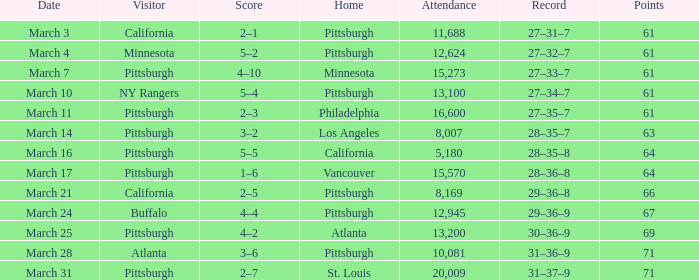What is the Score of the game with a Record of 31–37–9? 2–7. 